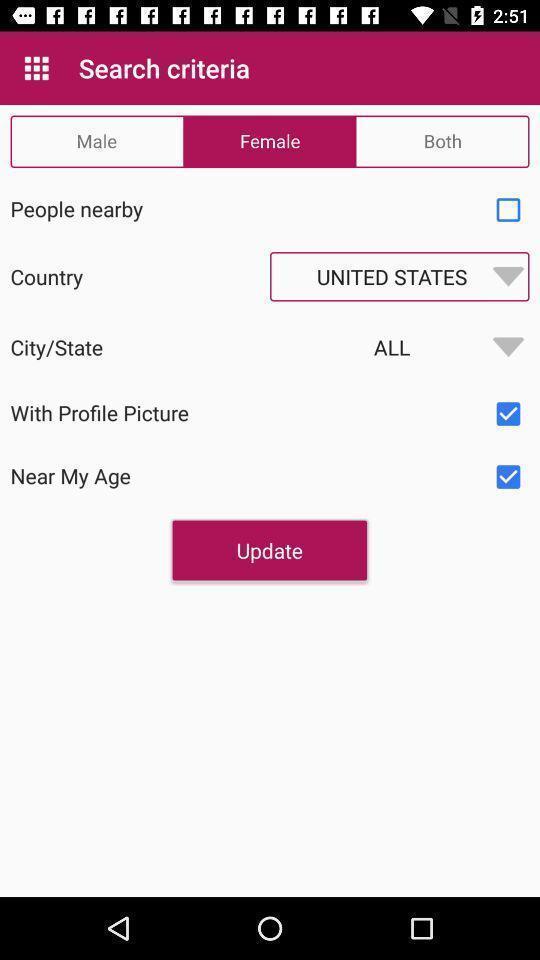Describe this image in words. Window displaying a dating app. 